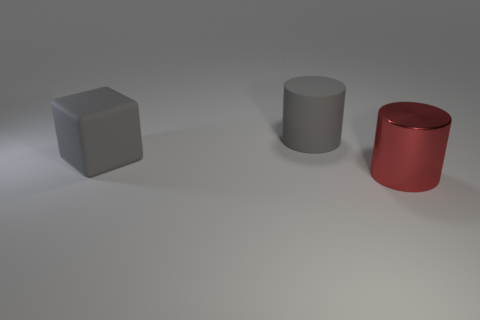Is there anything else that is the same material as the red object?
Your response must be concise. No. What number of big rubber objects are right of the matte cylinder?
Offer a very short reply. 0. Is the color of the rubber thing that is in front of the gray cylinder the same as the cylinder that is behind the red cylinder?
Your answer should be compact. Yes. The large matte object that is the same shape as the large red metallic thing is what color?
Give a very brief answer. Gray. Do the large gray thing that is to the right of the rubber cube and the red metal object that is in front of the big matte block have the same shape?
Offer a terse response. Yes. There is a shiny thing; does it have the same size as the cylinder that is on the left side of the big red thing?
Offer a very short reply. Yes. Is the number of big red shiny cylinders greater than the number of small cyan metal spheres?
Provide a short and direct response. Yes. Are the large cylinder that is in front of the cube and the big cylinder that is on the left side of the red metal object made of the same material?
Your answer should be compact. No. What material is the cube?
Offer a terse response. Rubber. Are there more red metallic objects to the right of the red cylinder than cubes?
Keep it short and to the point. No. 